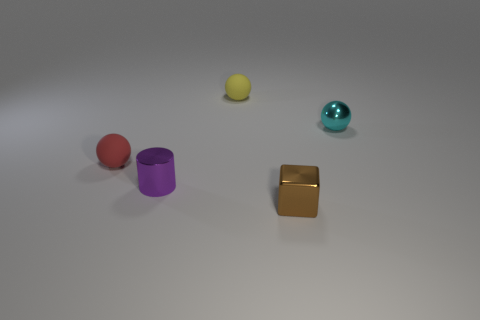Add 3 red rubber things. How many objects exist? 8 Subtract all cyan metallic spheres. How many spheres are left? 2 Subtract all cubes. How many objects are left? 4 Add 5 small yellow spheres. How many small yellow spheres are left? 6 Add 3 tiny purple shiny objects. How many tiny purple shiny objects exist? 4 Subtract all yellow balls. How many balls are left? 2 Subtract 1 purple cylinders. How many objects are left? 4 Subtract 1 spheres. How many spheres are left? 2 Subtract all red blocks. Subtract all gray cylinders. How many blocks are left? 1 Subtract all gray cylinders. How many cyan balls are left? 1 